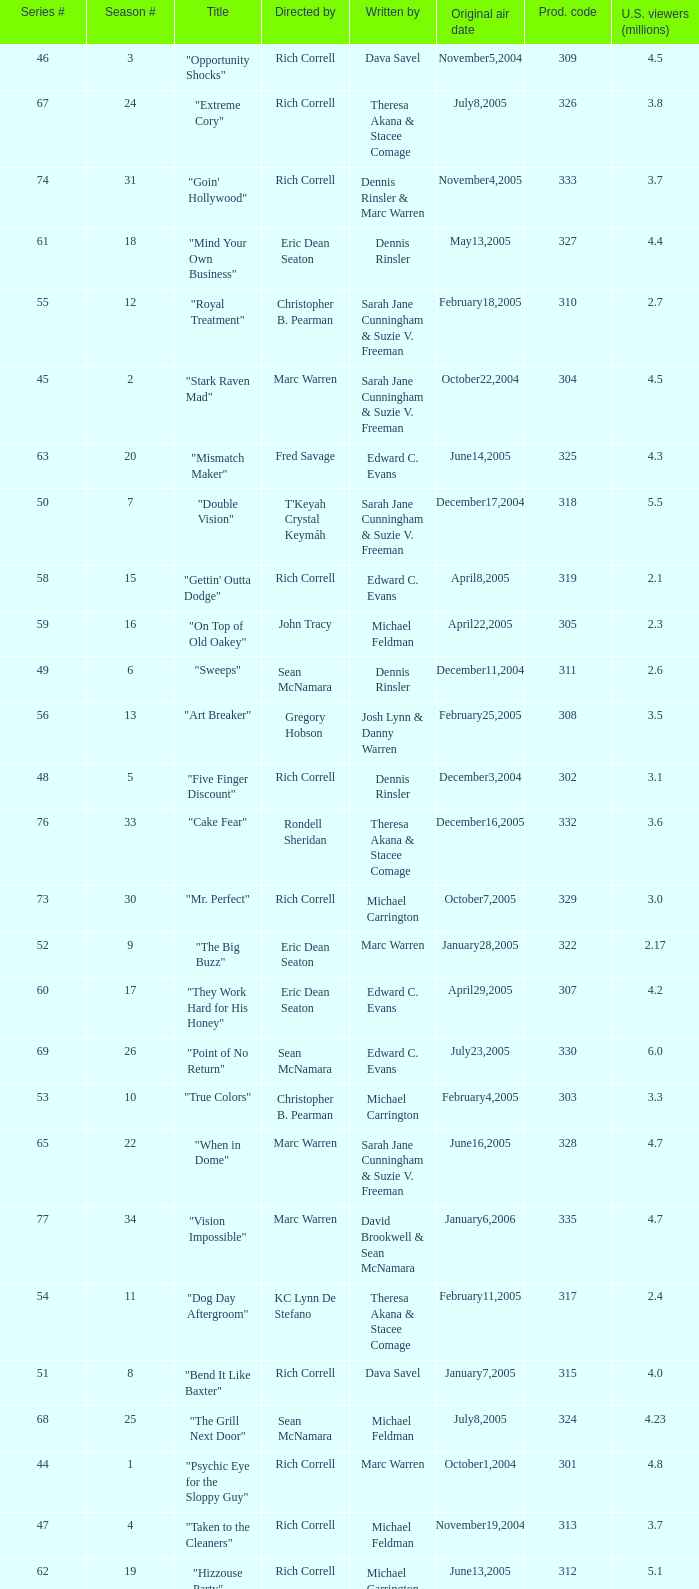What number episode of the season was titled "Vision Impossible"? 34.0. Would you mind parsing the complete table? {'header': ['Series #', 'Season #', 'Title', 'Directed by', 'Written by', 'Original air date', 'Prod. code', 'U.S. viewers (millions)'], 'rows': [['46', '3', '"Opportunity Shocks"', 'Rich Correll', 'Dava Savel', 'November5,2004', '309', '4.5'], ['67', '24', '"Extreme Cory"', 'Rich Correll', 'Theresa Akana & Stacee Comage', 'July8,2005', '326', '3.8'], ['74', '31', '"Goin\' Hollywood"', 'Rich Correll', 'Dennis Rinsler & Marc Warren', 'November4,2005', '333', '3.7'], ['61', '18', '"Mind Your Own Business"', 'Eric Dean Seaton', 'Dennis Rinsler', 'May13,2005', '327', '4.4'], ['55', '12', '"Royal Treatment"', 'Christopher B. Pearman', 'Sarah Jane Cunningham & Suzie V. Freeman', 'February18,2005', '310', '2.7'], ['45', '2', '"Stark Raven Mad"', 'Marc Warren', 'Sarah Jane Cunningham & Suzie V. Freeman', 'October22,2004', '304', '4.5'], ['63', '20', '"Mismatch Maker"', 'Fred Savage', 'Edward C. Evans', 'June14,2005', '325', '4.3'], ['50', '7', '"Double Vision"', "T'Keyah Crystal Keymáh", 'Sarah Jane Cunningham & Suzie V. Freeman', 'December17,2004', '318', '5.5'], ['58', '15', '"Gettin\' Outta Dodge"', 'Rich Correll', 'Edward C. Evans', 'April8,2005', '319', '2.1'], ['59', '16', '"On Top of Old Oakey"', 'John Tracy', 'Michael Feldman', 'April22,2005', '305', '2.3'], ['49', '6', '"Sweeps"', 'Sean McNamara', 'Dennis Rinsler', 'December11,2004', '311', '2.6'], ['56', '13', '"Art Breaker"', 'Gregory Hobson', 'Josh Lynn & Danny Warren', 'February25,2005', '308', '3.5'], ['48', '5', '"Five Finger Discount"', 'Rich Correll', 'Dennis Rinsler', 'December3,2004', '302', '3.1'], ['76', '33', '"Cake Fear"', 'Rondell Sheridan', 'Theresa Akana & Stacee Comage', 'December16,2005', '332', '3.6'], ['73', '30', '"Mr. Perfect"', 'Rich Correll', 'Michael Carrington', 'October7,2005', '329', '3.0'], ['52', '9', '"The Big Buzz"', 'Eric Dean Seaton', 'Marc Warren', 'January28,2005', '322', '2.17'], ['60', '17', '"They Work Hard for His Honey"', 'Eric Dean Seaton', 'Edward C. Evans', 'April29,2005', '307', '4.2'], ['69', '26', '"Point of No Return"', 'Sean McNamara', 'Edward C. Evans', 'July23,2005', '330', '6.0'], ['53', '10', '"True Colors"', 'Christopher B. Pearman', 'Michael Carrington', 'February4,2005', '303', '3.3'], ['65', '22', '"When in Dome"', 'Marc Warren', 'Sarah Jane Cunningham & Suzie V. Freeman', 'June16,2005', '328', '4.7'], ['77', '34', '"Vision Impossible"', 'Marc Warren', 'David Brookwell & Sean McNamara', 'January6,2006', '335', '4.7'], ['54', '11', '"Dog Day Aftergroom"', 'KC Lynn De Stefano', 'Theresa Akana & Stacee Comage', 'February11,2005', '317', '2.4'], ['51', '8', '"Bend It Like Baxter"', 'Rich Correll', 'Dava Savel', 'January7,2005', '315', '4.0'], ['68', '25', '"The Grill Next Door"', 'Sean McNamara', 'Michael Feldman', 'July8,2005', '324', '4.23'], ['44', '1', '"Psychic Eye for the Sloppy Guy"', 'Rich Correll', 'Marc Warren', 'October1,2004', '301', '4.8'], ['47', '4', '"Taken to the Cleaners"', 'Rich Correll', 'Michael Feldman', 'November19,2004', '313', '3.7'], ['62', '19', '"Hizzouse Party"', 'Rich Correll', 'Michael Carrington', 'June13,2005', '312', '5.1'], ['75', '32', '"Save the Last Dance"', 'Sean McNamara', 'Marc Warren', 'November25,2005', '334', '3.3'], ['57', '14', '"Boyz \'N Commotion"', 'Debbie Allen', 'Theresa Akana & Stacee Comage', 'March11,2005', '306', '4.8'], ['72', '29', '"Food for Thought"', 'Rich Correll', 'Marc Warren', 'September18,2005', '316', '3.4'], ['66', '23', '"Too Much Pressure"', 'Rich Correll', 'Dava Savel', 'June17,2005', '323', '4.4']]} 